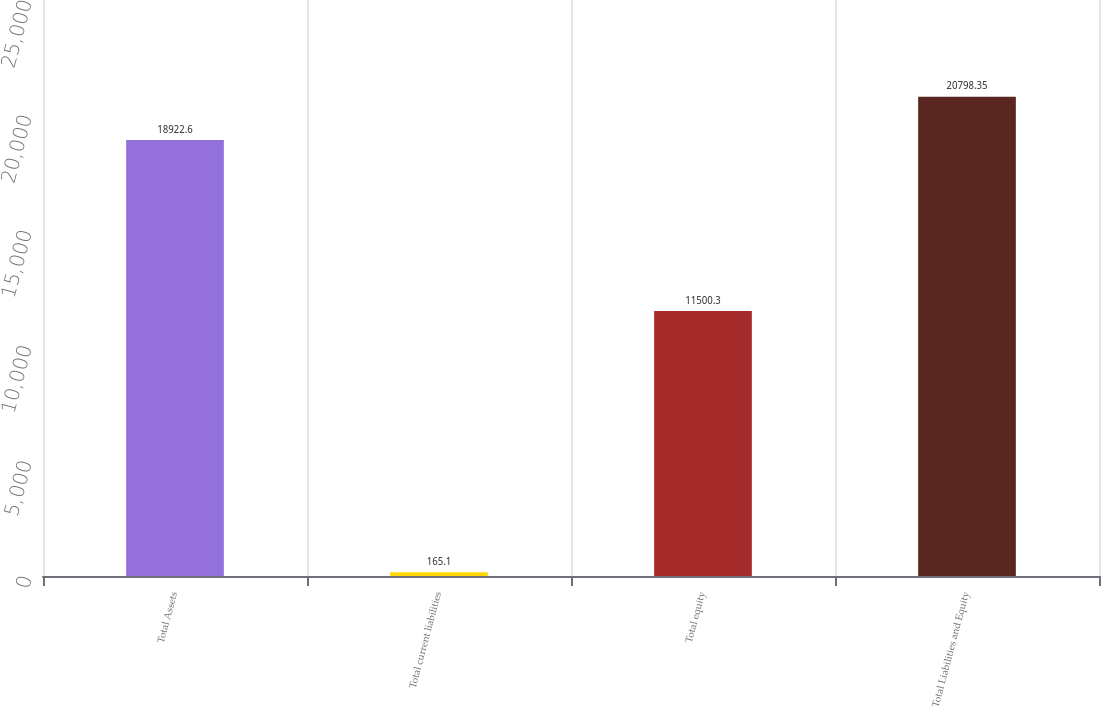<chart> <loc_0><loc_0><loc_500><loc_500><bar_chart><fcel>Total Assets<fcel>Total current liabilities<fcel>Total equity<fcel>Total Liabilities and Equity<nl><fcel>18922.6<fcel>165.1<fcel>11500.3<fcel>20798.3<nl></chart> 